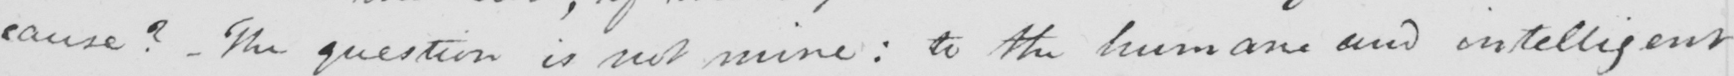What does this handwritten line say? cause ?   _  The question is not mine :  to the humane and intelligent 